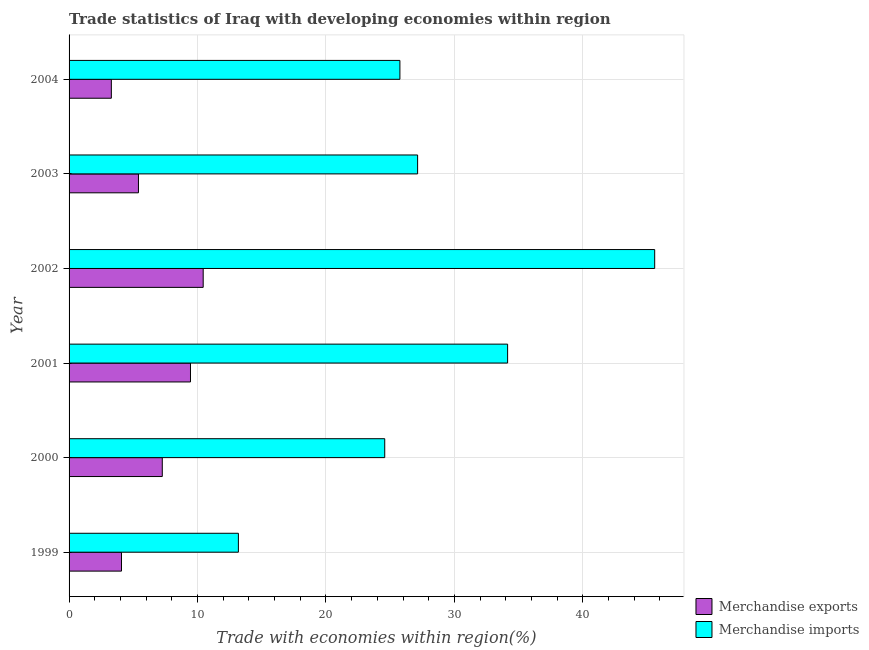How many different coloured bars are there?
Your answer should be very brief. 2. Are the number of bars per tick equal to the number of legend labels?
Provide a short and direct response. Yes. Are the number of bars on each tick of the Y-axis equal?
Make the answer very short. Yes. How many bars are there on the 5th tick from the bottom?
Offer a very short reply. 2. What is the merchandise imports in 2004?
Offer a very short reply. 25.76. Across all years, what is the maximum merchandise imports?
Keep it short and to the point. 45.59. Across all years, what is the minimum merchandise exports?
Provide a short and direct response. 3.29. In which year was the merchandise imports maximum?
Provide a short and direct response. 2002. In which year was the merchandise imports minimum?
Keep it short and to the point. 1999. What is the total merchandise exports in the graph?
Provide a short and direct response. 39.92. What is the difference between the merchandise exports in 2000 and that in 2003?
Give a very brief answer. 1.85. What is the difference between the merchandise exports in 2004 and the merchandise imports in 1999?
Your answer should be compact. -9.89. What is the average merchandise exports per year?
Your response must be concise. 6.65. In the year 1999, what is the difference between the merchandise imports and merchandise exports?
Your answer should be very brief. 9.1. In how many years, is the merchandise imports greater than 6 %?
Provide a short and direct response. 6. What is the ratio of the merchandise imports in 2000 to that in 2001?
Provide a short and direct response. 0.72. Is the merchandise exports in 1999 less than that in 2004?
Offer a terse response. No. What is the difference between the highest and the lowest merchandise imports?
Offer a terse response. 32.41. Is the sum of the merchandise imports in 2000 and 2004 greater than the maximum merchandise exports across all years?
Ensure brevity in your answer.  Yes. What does the 2nd bar from the bottom in 2004 represents?
Give a very brief answer. Merchandise imports. How many bars are there?
Make the answer very short. 12. How many years are there in the graph?
Offer a terse response. 6. What is the difference between two consecutive major ticks on the X-axis?
Provide a short and direct response. 10. Are the values on the major ticks of X-axis written in scientific E-notation?
Ensure brevity in your answer.  No. How many legend labels are there?
Your answer should be compact. 2. What is the title of the graph?
Your response must be concise. Trade statistics of Iraq with developing economies within region. Does "Commercial service imports" appear as one of the legend labels in the graph?
Provide a short and direct response. No. What is the label or title of the X-axis?
Provide a succinct answer. Trade with economies within region(%). What is the label or title of the Y-axis?
Keep it short and to the point. Year. What is the Trade with economies within region(%) of Merchandise exports in 1999?
Offer a very short reply. 4.08. What is the Trade with economies within region(%) in Merchandise imports in 1999?
Offer a very short reply. 13.18. What is the Trade with economies within region(%) in Merchandise exports in 2000?
Keep it short and to the point. 7.26. What is the Trade with economies within region(%) of Merchandise imports in 2000?
Provide a succinct answer. 24.57. What is the Trade with economies within region(%) in Merchandise exports in 2001?
Keep it short and to the point. 9.45. What is the Trade with economies within region(%) of Merchandise imports in 2001?
Offer a terse response. 34.14. What is the Trade with economies within region(%) of Merchandise exports in 2002?
Provide a succinct answer. 10.44. What is the Trade with economies within region(%) of Merchandise imports in 2002?
Make the answer very short. 45.59. What is the Trade with economies within region(%) of Merchandise exports in 2003?
Provide a succinct answer. 5.4. What is the Trade with economies within region(%) in Merchandise imports in 2003?
Your answer should be very brief. 27.13. What is the Trade with economies within region(%) of Merchandise exports in 2004?
Give a very brief answer. 3.29. What is the Trade with economies within region(%) of Merchandise imports in 2004?
Ensure brevity in your answer.  25.76. Across all years, what is the maximum Trade with economies within region(%) of Merchandise exports?
Provide a succinct answer. 10.44. Across all years, what is the maximum Trade with economies within region(%) of Merchandise imports?
Provide a succinct answer. 45.59. Across all years, what is the minimum Trade with economies within region(%) in Merchandise exports?
Make the answer very short. 3.29. Across all years, what is the minimum Trade with economies within region(%) of Merchandise imports?
Make the answer very short. 13.18. What is the total Trade with economies within region(%) in Merchandise exports in the graph?
Your response must be concise. 39.92. What is the total Trade with economies within region(%) of Merchandise imports in the graph?
Your response must be concise. 170.37. What is the difference between the Trade with economies within region(%) of Merchandise exports in 1999 and that in 2000?
Offer a terse response. -3.18. What is the difference between the Trade with economies within region(%) in Merchandise imports in 1999 and that in 2000?
Give a very brief answer. -11.39. What is the difference between the Trade with economies within region(%) in Merchandise exports in 1999 and that in 2001?
Provide a succinct answer. -5.37. What is the difference between the Trade with economies within region(%) of Merchandise imports in 1999 and that in 2001?
Your answer should be compact. -20.96. What is the difference between the Trade with economies within region(%) of Merchandise exports in 1999 and that in 2002?
Ensure brevity in your answer.  -6.36. What is the difference between the Trade with economies within region(%) in Merchandise imports in 1999 and that in 2002?
Your answer should be very brief. -32.41. What is the difference between the Trade with economies within region(%) of Merchandise exports in 1999 and that in 2003?
Offer a very short reply. -1.32. What is the difference between the Trade with economies within region(%) in Merchandise imports in 1999 and that in 2003?
Give a very brief answer. -13.95. What is the difference between the Trade with economies within region(%) of Merchandise exports in 1999 and that in 2004?
Give a very brief answer. 0.79. What is the difference between the Trade with economies within region(%) of Merchandise imports in 1999 and that in 2004?
Your answer should be compact. -12.57. What is the difference between the Trade with economies within region(%) in Merchandise exports in 2000 and that in 2001?
Offer a very short reply. -2.19. What is the difference between the Trade with economies within region(%) of Merchandise imports in 2000 and that in 2001?
Your answer should be compact. -9.56. What is the difference between the Trade with economies within region(%) in Merchandise exports in 2000 and that in 2002?
Make the answer very short. -3.18. What is the difference between the Trade with economies within region(%) in Merchandise imports in 2000 and that in 2002?
Keep it short and to the point. -21.01. What is the difference between the Trade with economies within region(%) of Merchandise exports in 2000 and that in 2003?
Offer a terse response. 1.86. What is the difference between the Trade with economies within region(%) in Merchandise imports in 2000 and that in 2003?
Provide a succinct answer. -2.56. What is the difference between the Trade with economies within region(%) in Merchandise exports in 2000 and that in 2004?
Give a very brief answer. 3.97. What is the difference between the Trade with economies within region(%) of Merchandise imports in 2000 and that in 2004?
Your answer should be compact. -1.18. What is the difference between the Trade with economies within region(%) of Merchandise exports in 2001 and that in 2002?
Your answer should be very brief. -0.99. What is the difference between the Trade with economies within region(%) of Merchandise imports in 2001 and that in 2002?
Provide a short and direct response. -11.45. What is the difference between the Trade with economies within region(%) in Merchandise exports in 2001 and that in 2003?
Provide a succinct answer. 4.05. What is the difference between the Trade with economies within region(%) in Merchandise imports in 2001 and that in 2003?
Your response must be concise. 7.01. What is the difference between the Trade with economies within region(%) of Merchandise exports in 2001 and that in 2004?
Provide a short and direct response. 6.16. What is the difference between the Trade with economies within region(%) in Merchandise imports in 2001 and that in 2004?
Give a very brief answer. 8.38. What is the difference between the Trade with economies within region(%) in Merchandise exports in 2002 and that in 2003?
Provide a short and direct response. 5.04. What is the difference between the Trade with economies within region(%) in Merchandise imports in 2002 and that in 2003?
Offer a terse response. 18.46. What is the difference between the Trade with economies within region(%) of Merchandise exports in 2002 and that in 2004?
Your response must be concise. 7.15. What is the difference between the Trade with economies within region(%) in Merchandise imports in 2002 and that in 2004?
Provide a succinct answer. 19.83. What is the difference between the Trade with economies within region(%) of Merchandise exports in 2003 and that in 2004?
Keep it short and to the point. 2.11. What is the difference between the Trade with economies within region(%) of Merchandise imports in 2003 and that in 2004?
Your answer should be compact. 1.38. What is the difference between the Trade with economies within region(%) of Merchandise exports in 1999 and the Trade with economies within region(%) of Merchandise imports in 2000?
Provide a short and direct response. -20.49. What is the difference between the Trade with economies within region(%) of Merchandise exports in 1999 and the Trade with economies within region(%) of Merchandise imports in 2001?
Give a very brief answer. -30.06. What is the difference between the Trade with economies within region(%) of Merchandise exports in 1999 and the Trade with economies within region(%) of Merchandise imports in 2002?
Your answer should be compact. -41.51. What is the difference between the Trade with economies within region(%) in Merchandise exports in 1999 and the Trade with economies within region(%) in Merchandise imports in 2003?
Offer a terse response. -23.05. What is the difference between the Trade with economies within region(%) in Merchandise exports in 1999 and the Trade with economies within region(%) in Merchandise imports in 2004?
Ensure brevity in your answer.  -21.68. What is the difference between the Trade with economies within region(%) of Merchandise exports in 2000 and the Trade with economies within region(%) of Merchandise imports in 2001?
Your answer should be very brief. -26.88. What is the difference between the Trade with economies within region(%) in Merchandise exports in 2000 and the Trade with economies within region(%) in Merchandise imports in 2002?
Your response must be concise. -38.33. What is the difference between the Trade with economies within region(%) in Merchandise exports in 2000 and the Trade with economies within region(%) in Merchandise imports in 2003?
Provide a short and direct response. -19.88. What is the difference between the Trade with economies within region(%) in Merchandise exports in 2000 and the Trade with economies within region(%) in Merchandise imports in 2004?
Your answer should be compact. -18.5. What is the difference between the Trade with economies within region(%) of Merchandise exports in 2001 and the Trade with economies within region(%) of Merchandise imports in 2002?
Offer a terse response. -36.14. What is the difference between the Trade with economies within region(%) in Merchandise exports in 2001 and the Trade with economies within region(%) in Merchandise imports in 2003?
Keep it short and to the point. -17.68. What is the difference between the Trade with economies within region(%) of Merchandise exports in 2001 and the Trade with economies within region(%) of Merchandise imports in 2004?
Provide a succinct answer. -16.3. What is the difference between the Trade with economies within region(%) in Merchandise exports in 2002 and the Trade with economies within region(%) in Merchandise imports in 2003?
Your answer should be very brief. -16.69. What is the difference between the Trade with economies within region(%) in Merchandise exports in 2002 and the Trade with economies within region(%) in Merchandise imports in 2004?
Your answer should be very brief. -15.31. What is the difference between the Trade with economies within region(%) of Merchandise exports in 2003 and the Trade with economies within region(%) of Merchandise imports in 2004?
Your answer should be very brief. -20.35. What is the average Trade with economies within region(%) of Merchandise exports per year?
Your answer should be very brief. 6.65. What is the average Trade with economies within region(%) in Merchandise imports per year?
Give a very brief answer. 28.4. In the year 1999, what is the difference between the Trade with economies within region(%) of Merchandise exports and Trade with economies within region(%) of Merchandise imports?
Your answer should be very brief. -9.1. In the year 2000, what is the difference between the Trade with economies within region(%) of Merchandise exports and Trade with economies within region(%) of Merchandise imports?
Provide a short and direct response. -17.32. In the year 2001, what is the difference between the Trade with economies within region(%) in Merchandise exports and Trade with economies within region(%) in Merchandise imports?
Your answer should be very brief. -24.69. In the year 2002, what is the difference between the Trade with economies within region(%) in Merchandise exports and Trade with economies within region(%) in Merchandise imports?
Give a very brief answer. -35.15. In the year 2003, what is the difference between the Trade with economies within region(%) of Merchandise exports and Trade with economies within region(%) of Merchandise imports?
Ensure brevity in your answer.  -21.73. In the year 2004, what is the difference between the Trade with economies within region(%) in Merchandise exports and Trade with economies within region(%) in Merchandise imports?
Make the answer very short. -22.46. What is the ratio of the Trade with economies within region(%) of Merchandise exports in 1999 to that in 2000?
Your response must be concise. 0.56. What is the ratio of the Trade with economies within region(%) of Merchandise imports in 1999 to that in 2000?
Your response must be concise. 0.54. What is the ratio of the Trade with economies within region(%) of Merchandise exports in 1999 to that in 2001?
Offer a very short reply. 0.43. What is the ratio of the Trade with economies within region(%) of Merchandise imports in 1999 to that in 2001?
Your answer should be compact. 0.39. What is the ratio of the Trade with economies within region(%) in Merchandise exports in 1999 to that in 2002?
Your answer should be very brief. 0.39. What is the ratio of the Trade with economies within region(%) in Merchandise imports in 1999 to that in 2002?
Make the answer very short. 0.29. What is the ratio of the Trade with economies within region(%) of Merchandise exports in 1999 to that in 2003?
Provide a succinct answer. 0.76. What is the ratio of the Trade with economies within region(%) of Merchandise imports in 1999 to that in 2003?
Offer a very short reply. 0.49. What is the ratio of the Trade with economies within region(%) of Merchandise exports in 1999 to that in 2004?
Offer a terse response. 1.24. What is the ratio of the Trade with economies within region(%) of Merchandise imports in 1999 to that in 2004?
Provide a succinct answer. 0.51. What is the ratio of the Trade with economies within region(%) of Merchandise exports in 2000 to that in 2001?
Your answer should be very brief. 0.77. What is the ratio of the Trade with economies within region(%) of Merchandise imports in 2000 to that in 2001?
Your answer should be compact. 0.72. What is the ratio of the Trade with economies within region(%) in Merchandise exports in 2000 to that in 2002?
Your answer should be compact. 0.69. What is the ratio of the Trade with economies within region(%) in Merchandise imports in 2000 to that in 2002?
Ensure brevity in your answer.  0.54. What is the ratio of the Trade with economies within region(%) in Merchandise exports in 2000 to that in 2003?
Your answer should be compact. 1.34. What is the ratio of the Trade with economies within region(%) of Merchandise imports in 2000 to that in 2003?
Your answer should be very brief. 0.91. What is the ratio of the Trade with economies within region(%) in Merchandise exports in 2000 to that in 2004?
Provide a short and direct response. 2.21. What is the ratio of the Trade with economies within region(%) in Merchandise imports in 2000 to that in 2004?
Provide a short and direct response. 0.95. What is the ratio of the Trade with economies within region(%) in Merchandise exports in 2001 to that in 2002?
Your answer should be very brief. 0.91. What is the ratio of the Trade with economies within region(%) of Merchandise imports in 2001 to that in 2002?
Ensure brevity in your answer.  0.75. What is the ratio of the Trade with economies within region(%) of Merchandise exports in 2001 to that in 2003?
Provide a succinct answer. 1.75. What is the ratio of the Trade with economies within region(%) of Merchandise imports in 2001 to that in 2003?
Ensure brevity in your answer.  1.26. What is the ratio of the Trade with economies within region(%) of Merchandise exports in 2001 to that in 2004?
Your answer should be very brief. 2.87. What is the ratio of the Trade with economies within region(%) of Merchandise imports in 2001 to that in 2004?
Keep it short and to the point. 1.33. What is the ratio of the Trade with economies within region(%) in Merchandise exports in 2002 to that in 2003?
Keep it short and to the point. 1.93. What is the ratio of the Trade with economies within region(%) of Merchandise imports in 2002 to that in 2003?
Offer a very short reply. 1.68. What is the ratio of the Trade with economies within region(%) of Merchandise exports in 2002 to that in 2004?
Make the answer very short. 3.17. What is the ratio of the Trade with economies within region(%) of Merchandise imports in 2002 to that in 2004?
Give a very brief answer. 1.77. What is the ratio of the Trade with economies within region(%) in Merchandise exports in 2003 to that in 2004?
Keep it short and to the point. 1.64. What is the ratio of the Trade with economies within region(%) in Merchandise imports in 2003 to that in 2004?
Make the answer very short. 1.05. What is the difference between the highest and the second highest Trade with economies within region(%) of Merchandise exports?
Offer a very short reply. 0.99. What is the difference between the highest and the second highest Trade with economies within region(%) of Merchandise imports?
Ensure brevity in your answer.  11.45. What is the difference between the highest and the lowest Trade with economies within region(%) of Merchandise exports?
Offer a very short reply. 7.15. What is the difference between the highest and the lowest Trade with economies within region(%) in Merchandise imports?
Your answer should be compact. 32.41. 